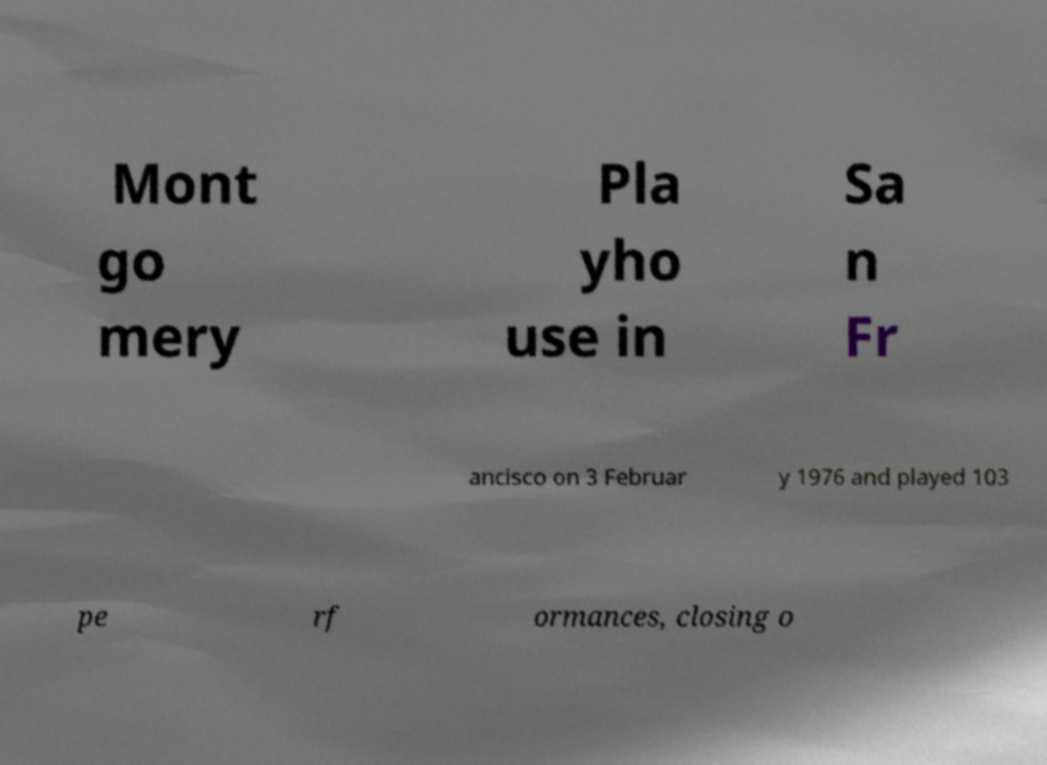There's text embedded in this image that I need extracted. Can you transcribe it verbatim? Mont go mery Pla yho use in Sa n Fr ancisco on 3 Februar y 1976 and played 103 pe rf ormances, closing o 